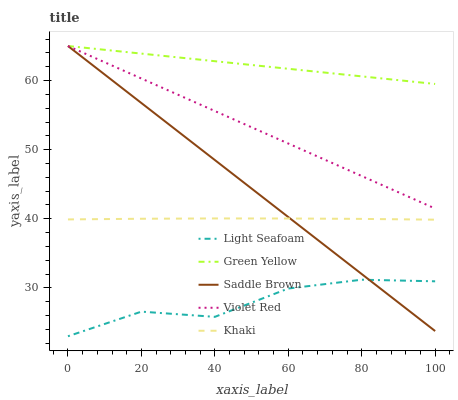Does Light Seafoam have the minimum area under the curve?
Answer yes or no. Yes. Does Green Yellow have the maximum area under the curve?
Answer yes or no. Yes. Does Green Yellow have the minimum area under the curve?
Answer yes or no. No. Does Light Seafoam have the maximum area under the curve?
Answer yes or no. No. Is Saddle Brown the smoothest?
Answer yes or no. Yes. Is Light Seafoam the roughest?
Answer yes or no. Yes. Is Green Yellow the smoothest?
Answer yes or no. No. Is Green Yellow the roughest?
Answer yes or no. No. Does Light Seafoam have the lowest value?
Answer yes or no. Yes. Does Green Yellow have the lowest value?
Answer yes or no. No. Does Saddle Brown have the highest value?
Answer yes or no. Yes. Does Light Seafoam have the highest value?
Answer yes or no. No. Is Khaki less than Violet Red?
Answer yes or no. Yes. Is Violet Red greater than Khaki?
Answer yes or no. Yes. Does Light Seafoam intersect Saddle Brown?
Answer yes or no. Yes. Is Light Seafoam less than Saddle Brown?
Answer yes or no. No. Is Light Seafoam greater than Saddle Brown?
Answer yes or no. No. Does Khaki intersect Violet Red?
Answer yes or no. No. 